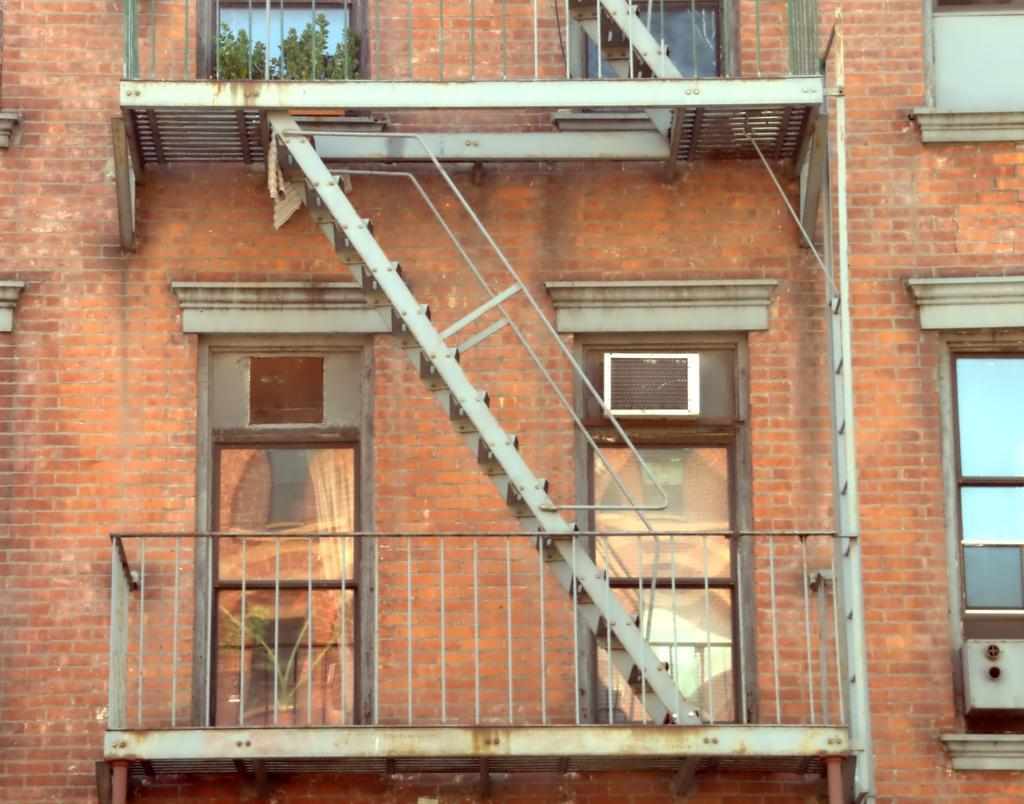In one or two sentences, can you explain what this image depicts? In this image I can see a building with brick walls. I can see windows, a metal construction of stairs and a balcony in the center attached to the building. 